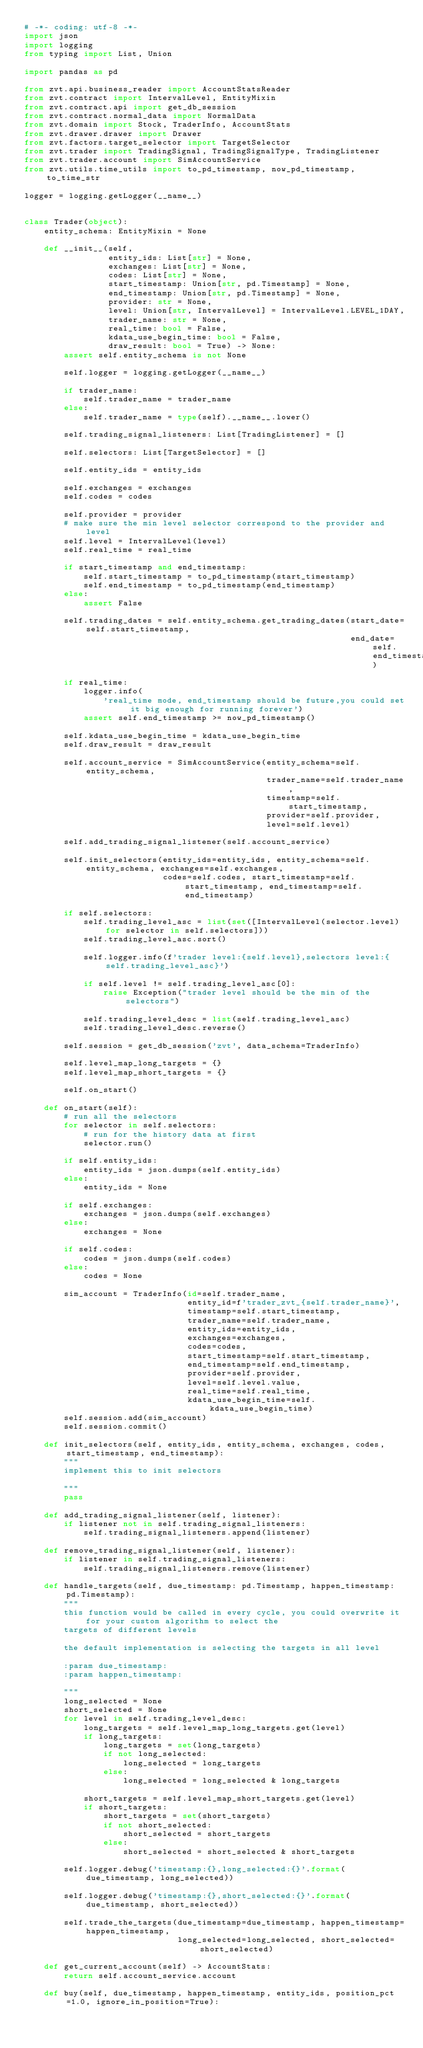<code> <loc_0><loc_0><loc_500><loc_500><_Python_># -*- coding: utf-8 -*-
import json
import logging
from typing import List, Union

import pandas as pd

from zvt.api.business_reader import AccountStatsReader
from zvt.contract import IntervalLevel, EntityMixin
from zvt.contract.api import get_db_session
from zvt.contract.normal_data import NormalData
from zvt.domain import Stock, TraderInfo, AccountStats
from zvt.drawer.drawer import Drawer
from zvt.factors.target_selector import TargetSelector
from zvt.trader import TradingSignal, TradingSignalType, TradingListener
from zvt.trader.account import SimAccountService
from zvt.utils.time_utils import to_pd_timestamp, now_pd_timestamp, to_time_str

logger = logging.getLogger(__name__)


class Trader(object):
    entity_schema: EntityMixin = None

    def __init__(self,
                 entity_ids: List[str] = None,
                 exchanges: List[str] = None,
                 codes: List[str] = None,
                 start_timestamp: Union[str, pd.Timestamp] = None,
                 end_timestamp: Union[str, pd.Timestamp] = None,
                 provider: str = None,
                 level: Union[str, IntervalLevel] = IntervalLevel.LEVEL_1DAY,
                 trader_name: str = None,
                 real_time: bool = False,
                 kdata_use_begin_time: bool = False,
                 draw_result: bool = True) -> None:
        assert self.entity_schema is not None

        self.logger = logging.getLogger(__name__)

        if trader_name:
            self.trader_name = trader_name
        else:
            self.trader_name = type(self).__name__.lower()

        self.trading_signal_listeners: List[TradingListener] = []

        self.selectors: List[TargetSelector] = []

        self.entity_ids = entity_ids

        self.exchanges = exchanges
        self.codes = codes

        self.provider = provider
        # make sure the min level selector correspond to the provider and level
        self.level = IntervalLevel(level)
        self.real_time = real_time

        if start_timestamp and end_timestamp:
            self.start_timestamp = to_pd_timestamp(start_timestamp)
            self.end_timestamp = to_pd_timestamp(end_timestamp)
        else:
            assert False

        self.trading_dates = self.entity_schema.get_trading_dates(start_date=self.start_timestamp,
                                                                  end_date=self.end_timestamp)

        if real_time:
            logger.info(
                'real_time mode, end_timestamp should be future,you could set it big enough for running forever')
            assert self.end_timestamp >= now_pd_timestamp()

        self.kdata_use_begin_time = kdata_use_begin_time
        self.draw_result = draw_result

        self.account_service = SimAccountService(entity_schema=self.entity_schema,
                                                 trader_name=self.trader_name,
                                                 timestamp=self.start_timestamp,
                                                 provider=self.provider,
                                                 level=self.level)

        self.add_trading_signal_listener(self.account_service)

        self.init_selectors(entity_ids=entity_ids, entity_schema=self.entity_schema, exchanges=self.exchanges,
                            codes=self.codes, start_timestamp=self.start_timestamp, end_timestamp=self.end_timestamp)

        if self.selectors:
            self.trading_level_asc = list(set([IntervalLevel(selector.level) for selector in self.selectors]))
            self.trading_level_asc.sort()

            self.logger.info(f'trader level:{self.level},selectors level:{self.trading_level_asc}')

            if self.level != self.trading_level_asc[0]:
                raise Exception("trader level should be the min of the selectors")

            self.trading_level_desc = list(self.trading_level_asc)
            self.trading_level_desc.reverse()

        self.session = get_db_session('zvt', data_schema=TraderInfo)

        self.level_map_long_targets = {}
        self.level_map_short_targets = {}

        self.on_start()

    def on_start(self):
        # run all the selectors
        for selector in self.selectors:
            # run for the history data at first
            selector.run()

        if self.entity_ids:
            entity_ids = json.dumps(self.entity_ids)
        else:
            entity_ids = None

        if self.exchanges:
            exchanges = json.dumps(self.exchanges)
        else:
            exchanges = None

        if self.codes:
            codes = json.dumps(self.codes)
        else:
            codes = None

        sim_account = TraderInfo(id=self.trader_name,
                                 entity_id=f'trader_zvt_{self.trader_name}',
                                 timestamp=self.start_timestamp,
                                 trader_name=self.trader_name,
                                 entity_ids=entity_ids,
                                 exchanges=exchanges,
                                 codes=codes,
                                 start_timestamp=self.start_timestamp,
                                 end_timestamp=self.end_timestamp,
                                 provider=self.provider,
                                 level=self.level.value,
                                 real_time=self.real_time,
                                 kdata_use_begin_time=self.kdata_use_begin_time)
        self.session.add(sim_account)
        self.session.commit()

    def init_selectors(self, entity_ids, entity_schema, exchanges, codes, start_timestamp, end_timestamp):
        """
        implement this to init selectors

        """
        pass

    def add_trading_signal_listener(self, listener):
        if listener not in self.trading_signal_listeners:
            self.trading_signal_listeners.append(listener)

    def remove_trading_signal_listener(self, listener):
        if listener in self.trading_signal_listeners:
            self.trading_signal_listeners.remove(listener)

    def handle_targets(self, due_timestamp: pd.Timestamp, happen_timestamp: pd.Timestamp):
        """
        this function would be called in every cycle, you could overwrite it for your custom algorithm to select the
        targets of different levels

        the default implementation is selecting the targets in all level

        :param due_timestamp:
        :param happen_timestamp:

        """
        long_selected = None
        short_selected = None
        for level in self.trading_level_desc:
            long_targets = self.level_map_long_targets.get(level)
            if long_targets:
                long_targets = set(long_targets)
                if not long_selected:
                    long_selected = long_targets
                else:
                    long_selected = long_selected & long_targets

            short_targets = self.level_map_short_targets.get(level)
            if short_targets:
                short_targets = set(short_targets)
                if not short_selected:
                    short_selected = short_targets
                else:
                    short_selected = short_selected & short_targets

        self.logger.debug('timestamp:{},long_selected:{}'.format(due_timestamp, long_selected))

        self.logger.debug('timestamp:{},short_selected:{}'.format(due_timestamp, short_selected))

        self.trade_the_targets(due_timestamp=due_timestamp, happen_timestamp=happen_timestamp,
                               long_selected=long_selected, short_selected=short_selected)

    def get_current_account(self) -> AccountStats:
        return self.account_service.account

    def buy(self, due_timestamp, happen_timestamp, entity_ids, position_pct=1.0, ignore_in_position=True):</code> 